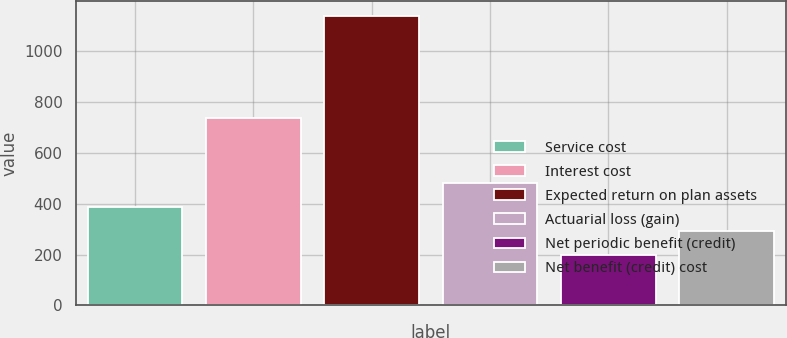Convert chart. <chart><loc_0><loc_0><loc_500><loc_500><bar_chart><fcel>Service cost<fcel>Interest cost<fcel>Expected return on plan assets<fcel>Actuarial loss (gain)<fcel>Net periodic benefit (credit)<fcel>Net benefit (credit) cost<nl><fcel>388<fcel>737<fcel>1140<fcel>482<fcel>200<fcel>294<nl></chart> 